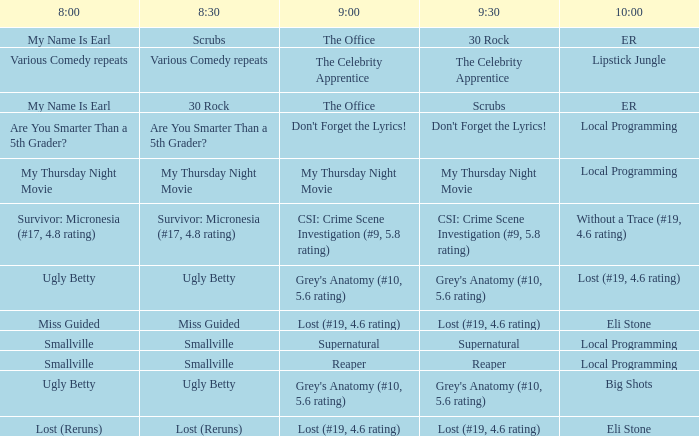What is at 10:00 when at 8:30 it is scrubs? ER. 